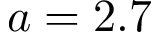Convert formula to latex. <formula><loc_0><loc_0><loc_500><loc_500>a = 2 . 7</formula> 